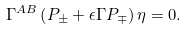Convert formula to latex. <formula><loc_0><loc_0><loc_500><loc_500>\Gamma ^ { A B } \left ( P _ { \pm } + \epsilon \Gamma P _ { \mp } \right ) \eta = 0 .</formula> 